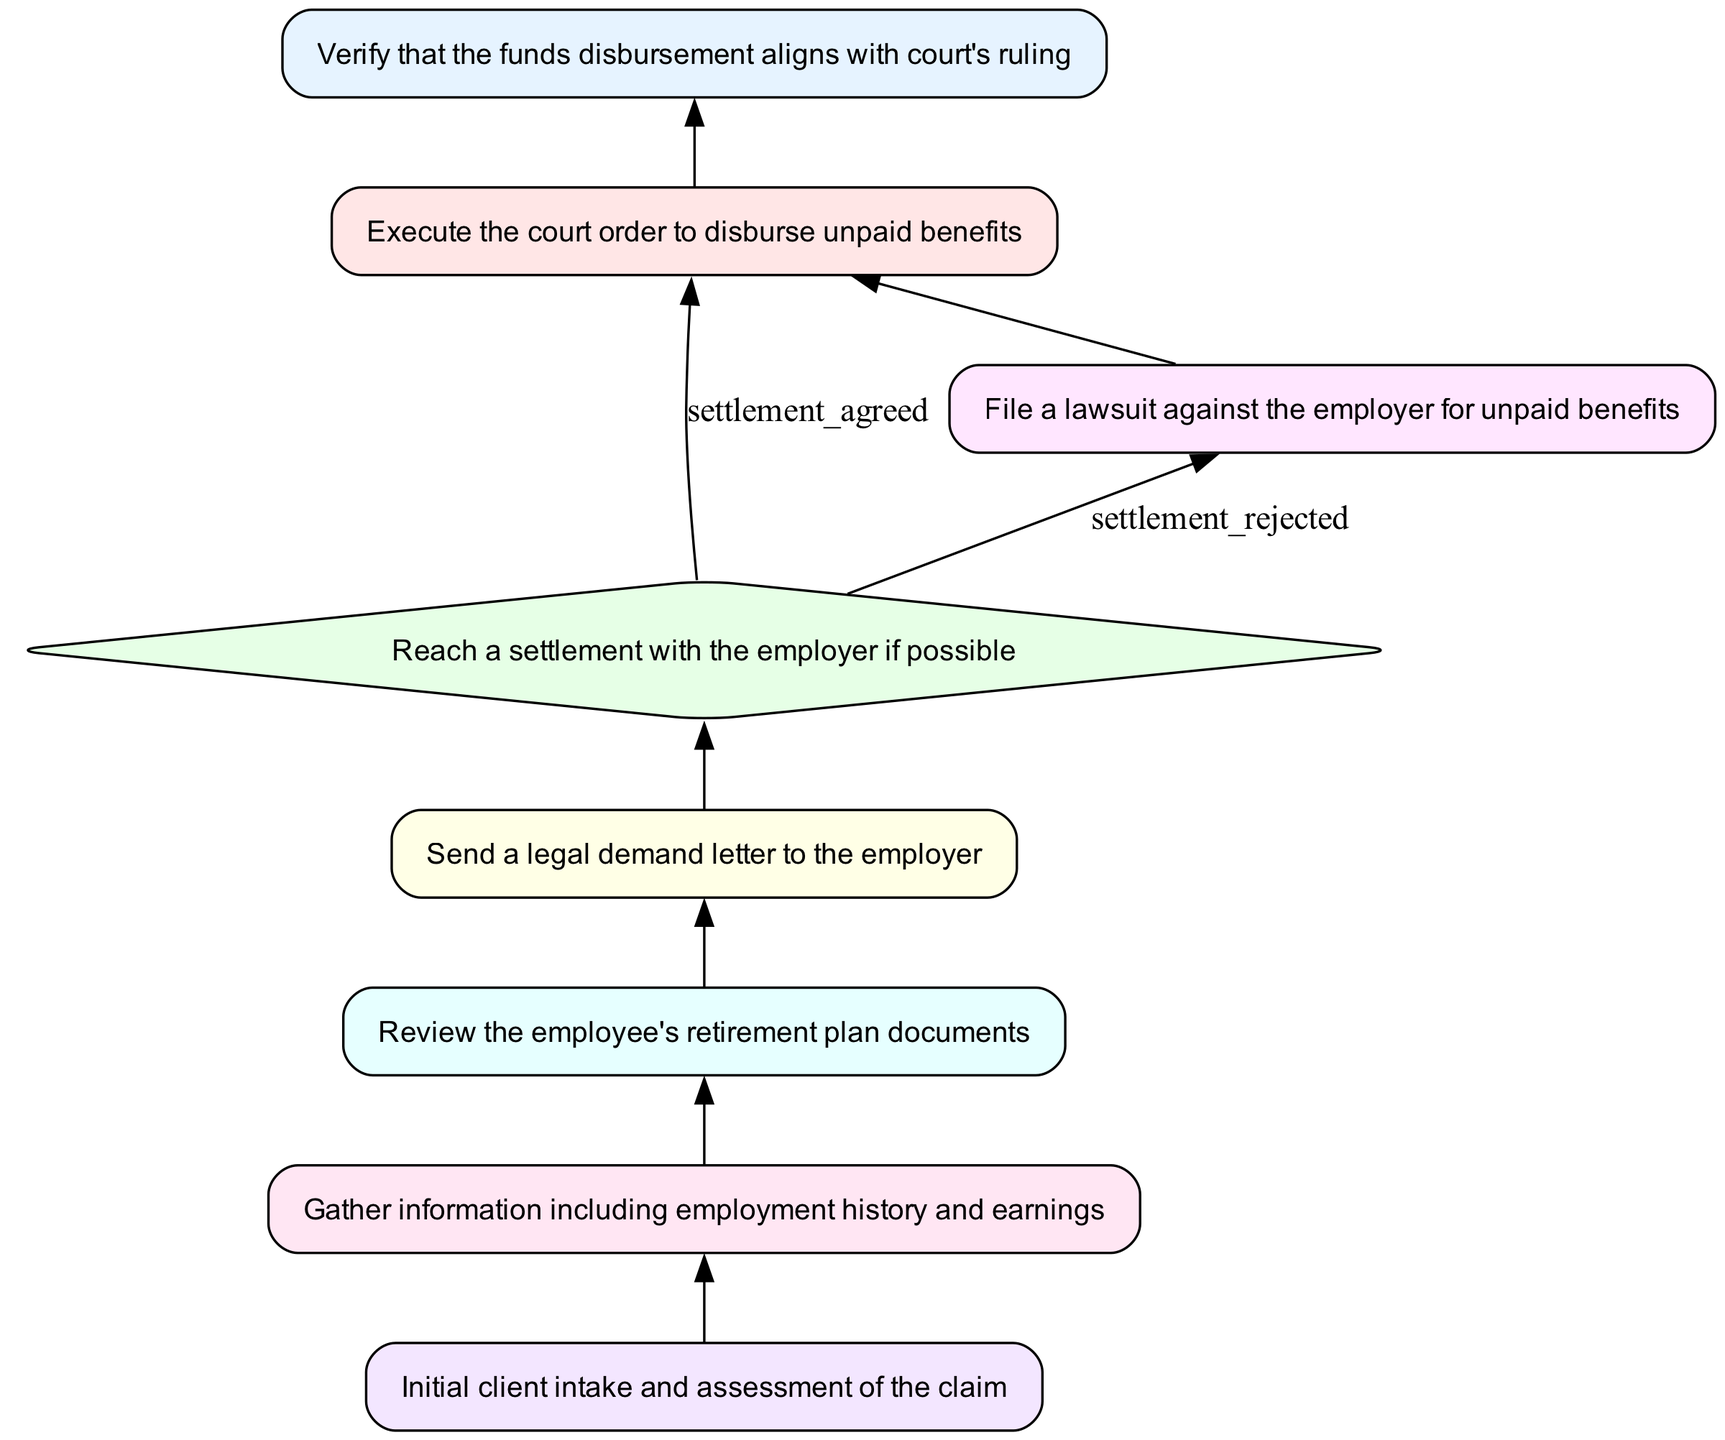What is the first step in the flowchart? The first step in the flowchart is "Initial client intake and assessment of the claim," which is represented by the node "client_intake." This is the starting point of the process.
Answer: Initial client intake and assessment of the claim How many functions are illustrated in the diagram? By counting the nodes marked as functions, we identify six function nodes: "verify_funds_disbursement," "execute_court_order," "initiate_lawsuit," "send_demand_letter," "review_retirement_plan," and "gather_employee_information."
Answer: Six What is the outcome if the settlement is rejected? If the settlement is rejected, the process flows to the "initiate_lawsuit" function, as indicated by the labeled edge from "reach_settlement."
Answer: Initiate lawsuit Which two nodes are directly linked to "send_demand_letter"? The nodes directly linked to "send_demand_letter" are "review_retirement_plan," which comes before it, and "reach_settlement," which comes after it. This shows a progression in the process.
Answer: Review retirement plan, reach settlement What happens after “execute_court_order”? After "execute_court_order," the next function to be executed is "verify_funds_disbursement," as shown by the directed edge from "execute_court_order" to "verify_funds_disbursement."
Answer: Verify funds disbursement If a settlement is reached, which function will be executed next? If a settlement is reached, the next function to be executed is "execute_court_order," as represented by the path from "reach_settlement" to "execute_court_order" if settlement_agreed.
Answer: Execute court order How are the steps sequenced in this flowchart? The steps are sequenced in a top-to-bottom order starting from "client_intake," followed by a series of functions that lead to the decision on reaching a settlement, which then diverges based on the outcome of that decision. This depicts a logical flow of actions and decisions in processing a legal claim.
Answer: Top-to-bottom sequence What is the purpose of the "review_retirement_plan" function? The purpose of "review_retirement_plan" is to involve examining the employee's retirement plan documents to gather relevant information before sending a demand letter. This function follows "gather_employee_information" in the process.
Answer: Examine retirement plan documents 